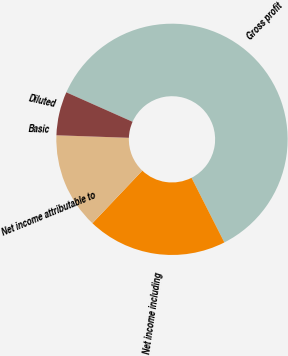<chart> <loc_0><loc_0><loc_500><loc_500><pie_chart><fcel>Gross profit<fcel>Net income including<fcel>Net income attributable to<fcel>Basic<fcel>Diluted<nl><fcel>60.86%<fcel>19.56%<fcel>13.47%<fcel>0.01%<fcel>6.1%<nl></chart> 